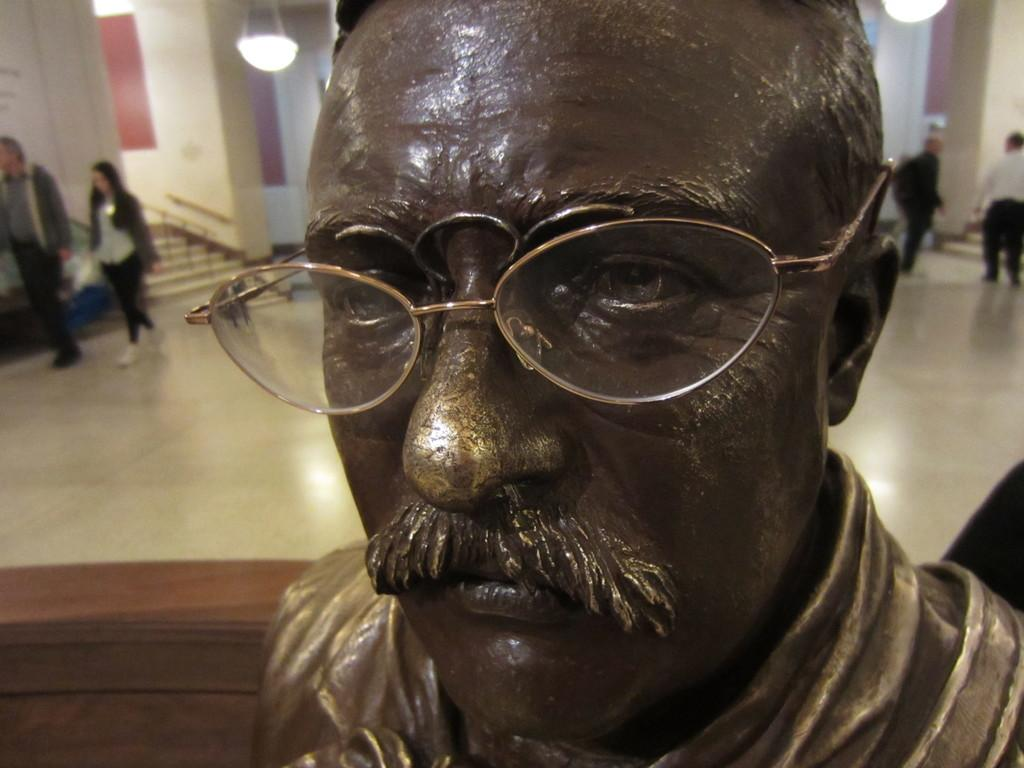What is the main subject in the foreground of the picture? There is a sculpture in the foreground of the picture. What can be seen in the background of the picture? There are people, pillars, lights, a staircase, and other objects in the background of the picture. Can you describe the architectural features visible in the background? Pillars are present in the background of the picture. What type of lighting is visible in the background? Lights are visible in the background of the picture. What type of vest is the club wearing in the image? There is no club or vest present in the image. How many legs does the sculpture have in the image? The provided facts do not mention the number of legs on the sculpture, so it cannot be determined from the image. 